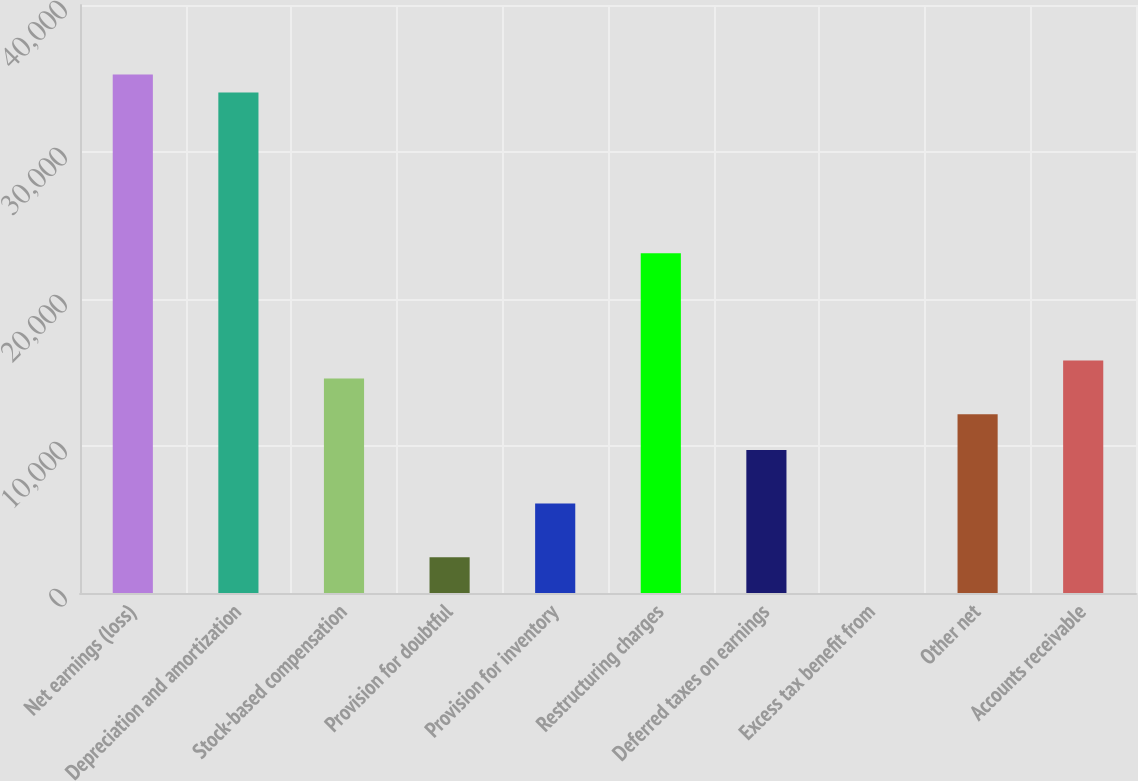Convert chart to OTSL. <chart><loc_0><loc_0><loc_500><loc_500><bar_chart><fcel>Net earnings (loss)<fcel>Depreciation and amortization<fcel>Stock-based compensation<fcel>Provision for doubtful<fcel>Provision for inventory<fcel>Restructuring charges<fcel>Deferred taxes on earnings<fcel>Excess tax benefit from<fcel>Other net<fcel>Accounts receivable<nl><fcel>35268.9<fcel>34052.8<fcel>14595.2<fcel>2434.2<fcel>6082.5<fcel>23107.9<fcel>9730.8<fcel>2<fcel>12163<fcel>15811.3<nl></chart> 